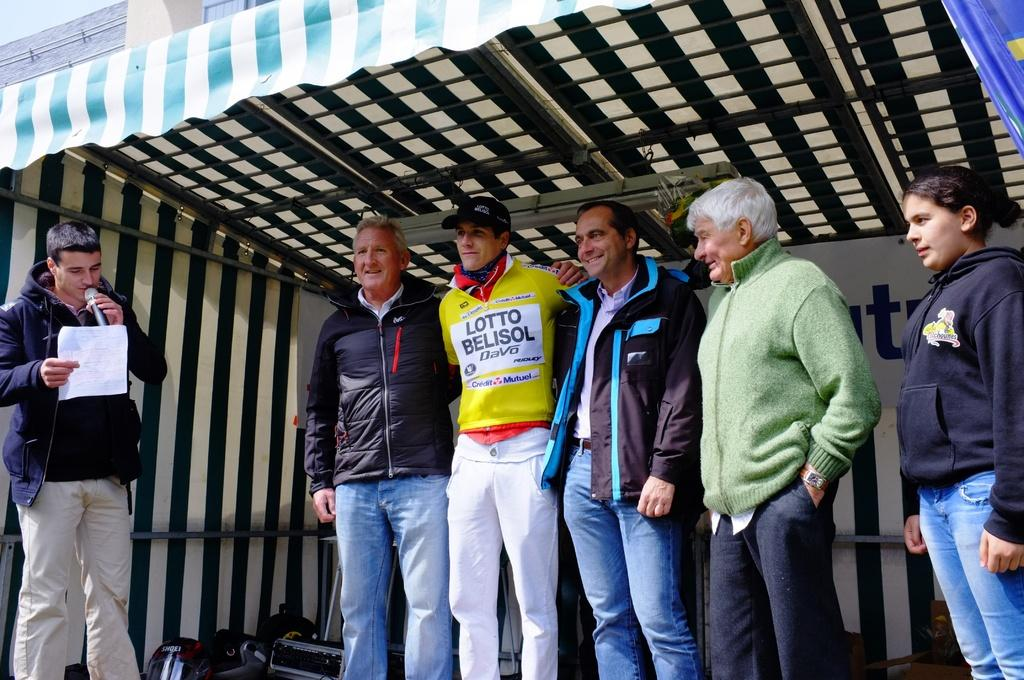<image>
Summarize the visual content of the image. Group of five people lined up for a photo the second person has a shirt that says Lotto Belisol. 